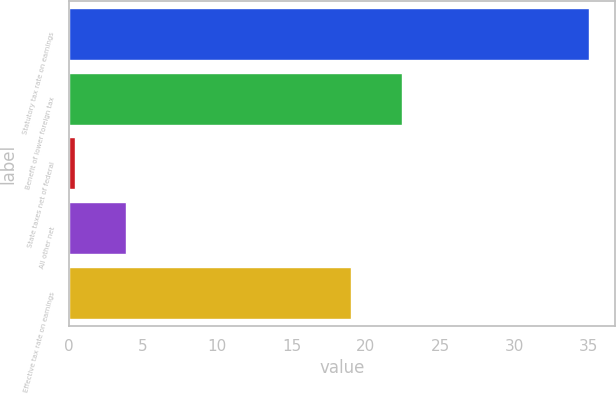Convert chart to OTSL. <chart><loc_0><loc_0><loc_500><loc_500><bar_chart><fcel>Statutory tax rate on earnings<fcel>Benefit of lower foreign tax<fcel>State taxes net of federal<fcel>All other net<fcel>Effective tax rate on earnings<nl><fcel>35<fcel>22.46<fcel>0.4<fcel>3.86<fcel>19<nl></chart> 